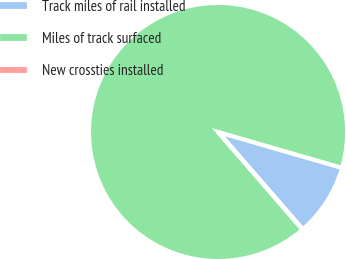Convert chart. <chart><loc_0><loc_0><loc_500><loc_500><pie_chart><fcel>Track miles of rail installed<fcel>Miles of track surfaced<fcel>New crossties installed<nl><fcel>9.12%<fcel>90.83%<fcel>0.04%<nl></chart> 